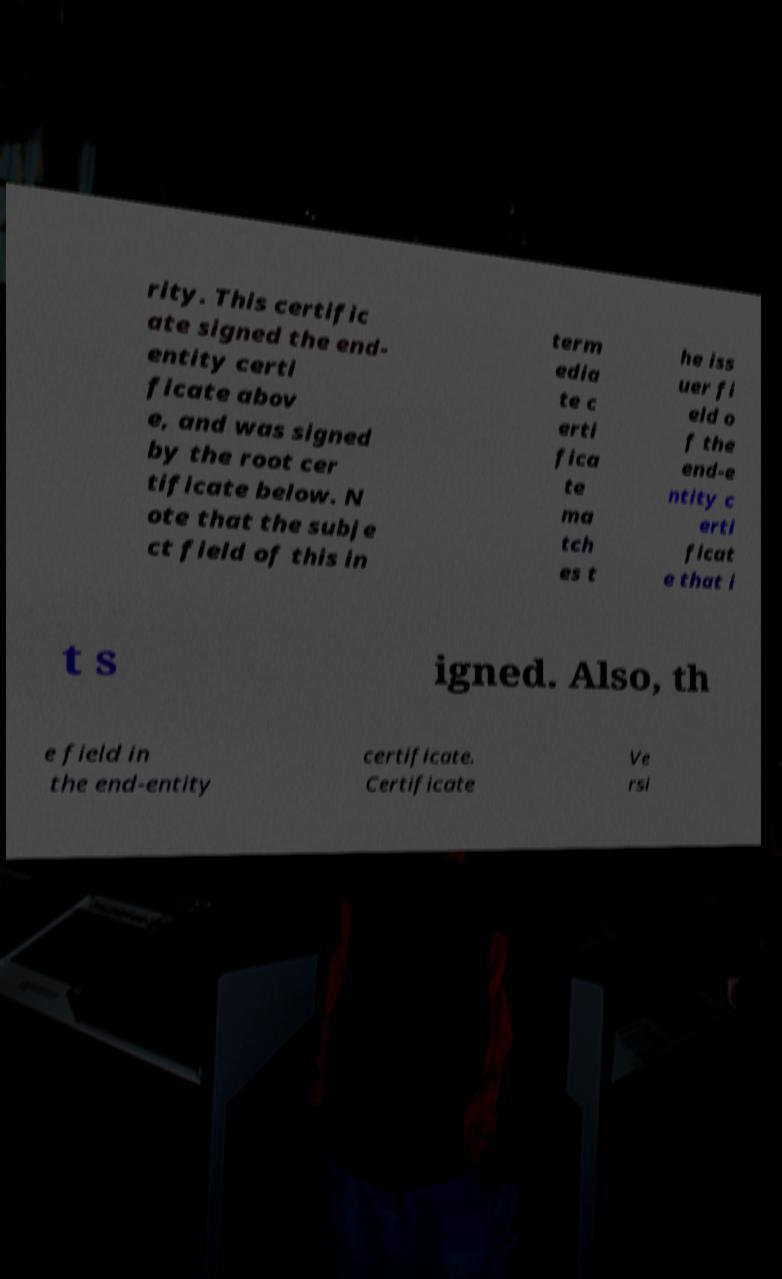For documentation purposes, I need the text within this image transcribed. Could you provide that? rity. This certific ate signed the end- entity certi ficate abov e, and was signed by the root cer tificate below. N ote that the subje ct field of this in term edia te c erti fica te ma tch es t he iss uer fi eld o f the end-e ntity c erti ficat e that i t s igned. Also, th e field in the end-entity certificate. Certificate Ve rsi 